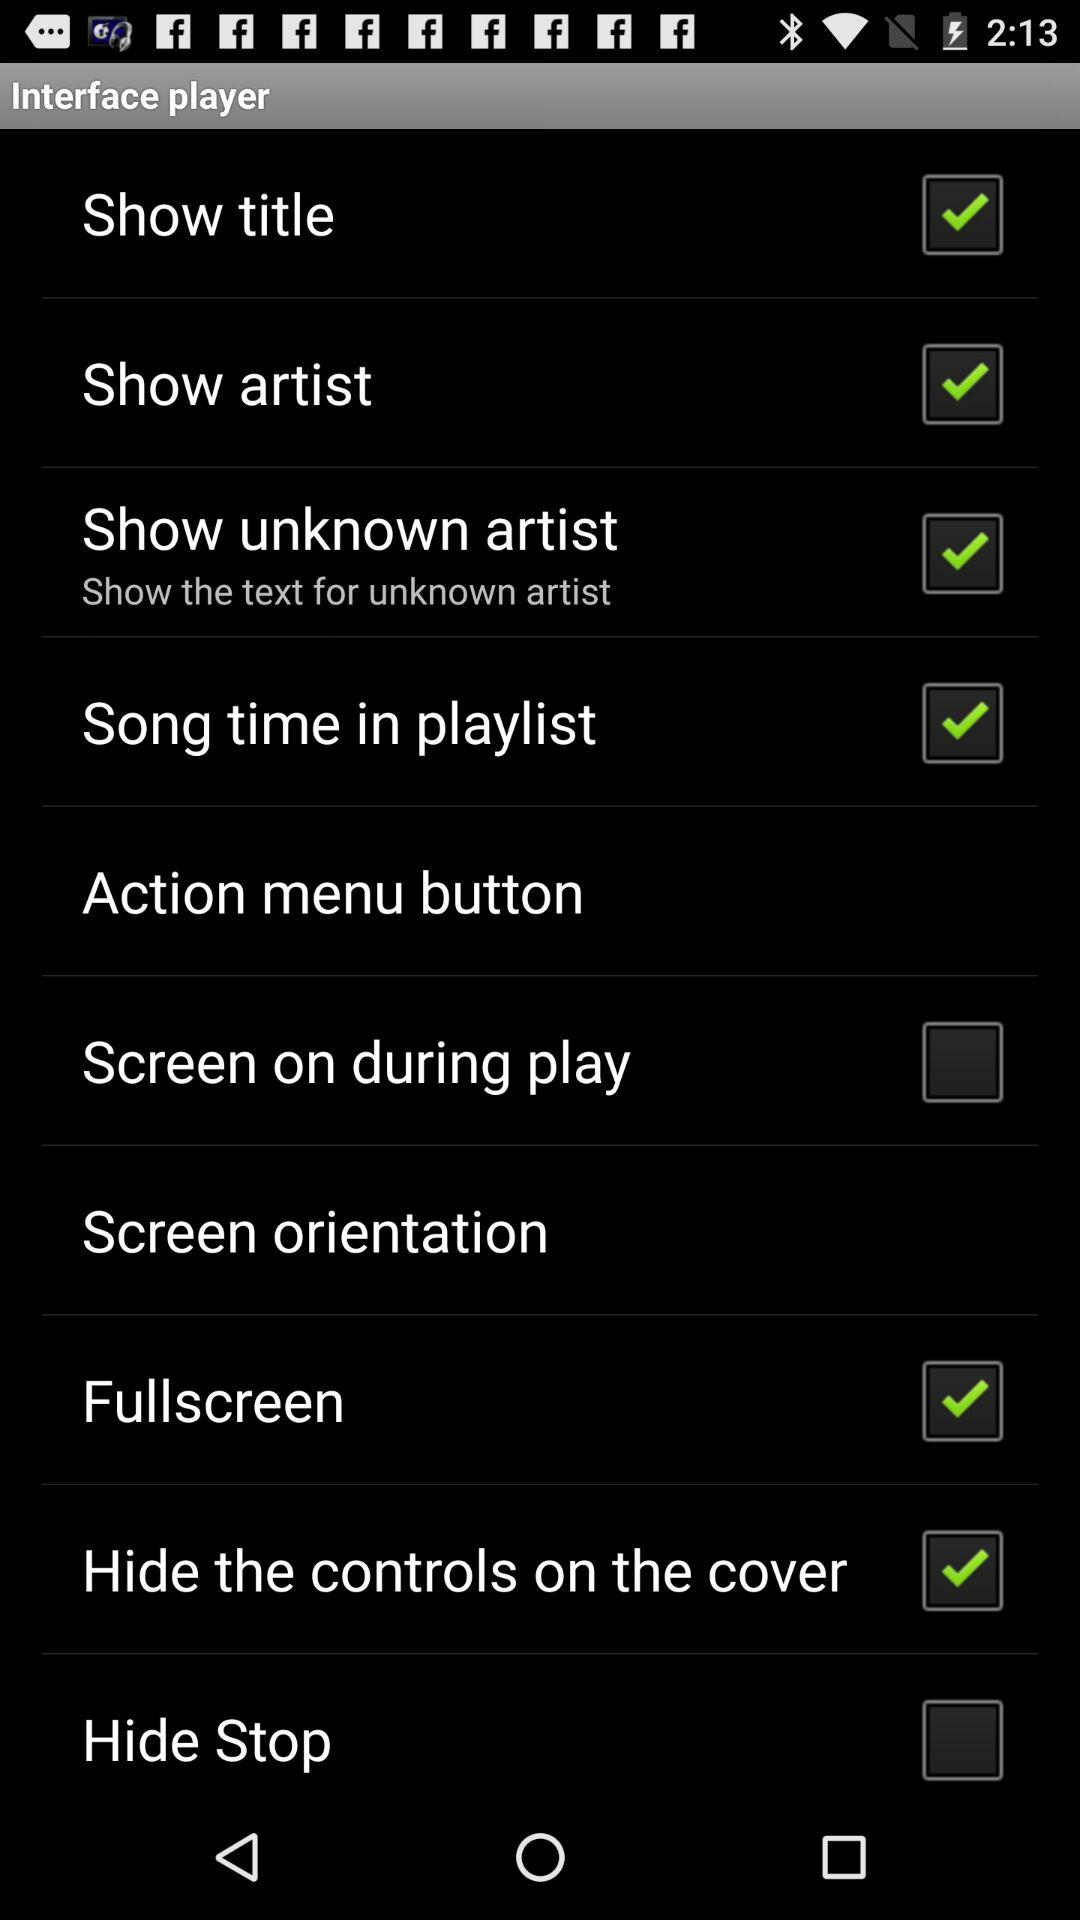Which options are marked as checked? The options are "Show title", "Show artist", "Show unknown artist", "Song time in playlist", "Fullscreen" and "Hide the controls on the cover". 